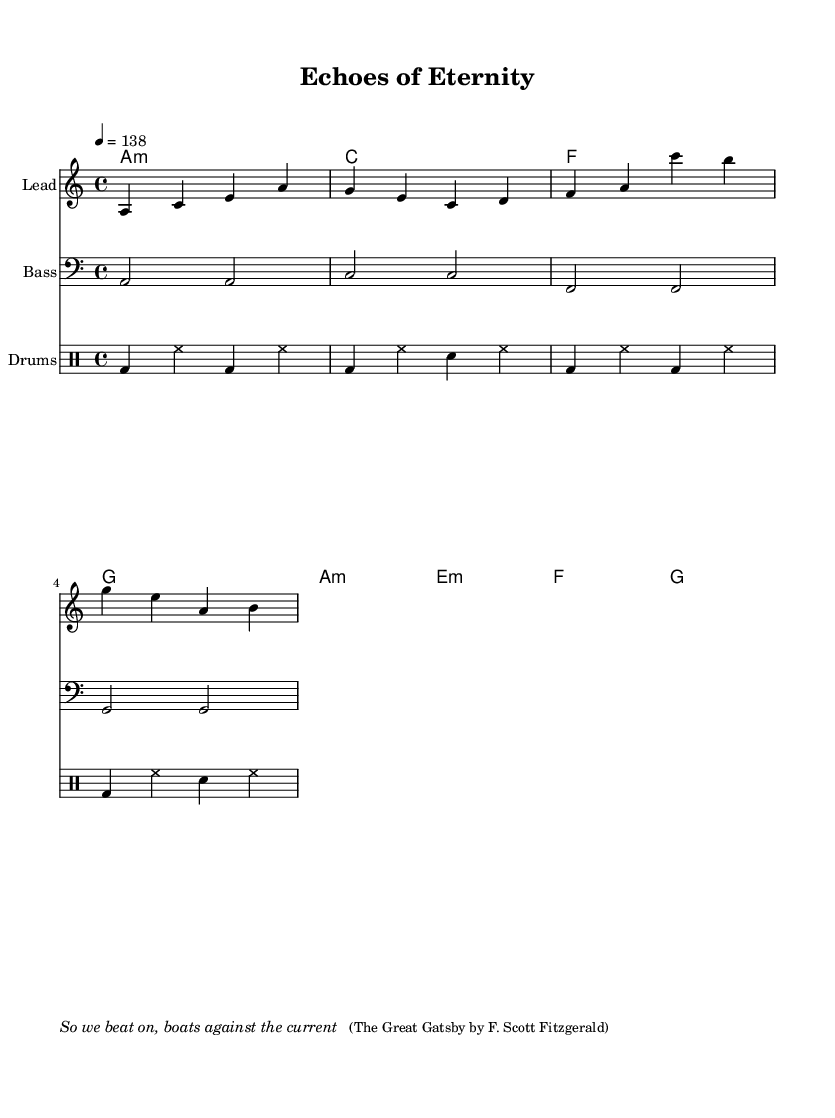What is the key signature of this music? The key signature is A minor, which is indicated by the absence of sharps or flats in the sheet music.
Answer: A minor What is the time signature of this music? The time signature is 4/4, which means there are four beats in each measure and the quarter note gets one beat. This is clearly stated at the beginning of the score.
Answer: 4/4 What is the tempo marking in this music? The tempo marking indicates a speed of 138 beats per minute, as shown by the "4 = 138" notation at the beginning.
Answer: 138 How many measures are in the melody? The melody consists of 8 measures, which can be counted from the notation of the melodic line provided. Each measure is visually separated.
Answer: 8 What is the instrument name for the first staff? The first staff is labeled as "Lead," which designates it for the lead melodic instrument.
Answer: Lead What type of dance music does this piece represent? This piece represents melodic trance, as indicated by the style and structure of the music, characterized by its ethereal melodies and rhythmic patterns typical of the genre.
Answer: Melodic trance What classic novel is quoted in this music? The quoted text is from "The Great Gatsby" by F. Scott Fitzgerald, which is provided in the markup section at the end of the score.
Answer: The Great Gatsby 